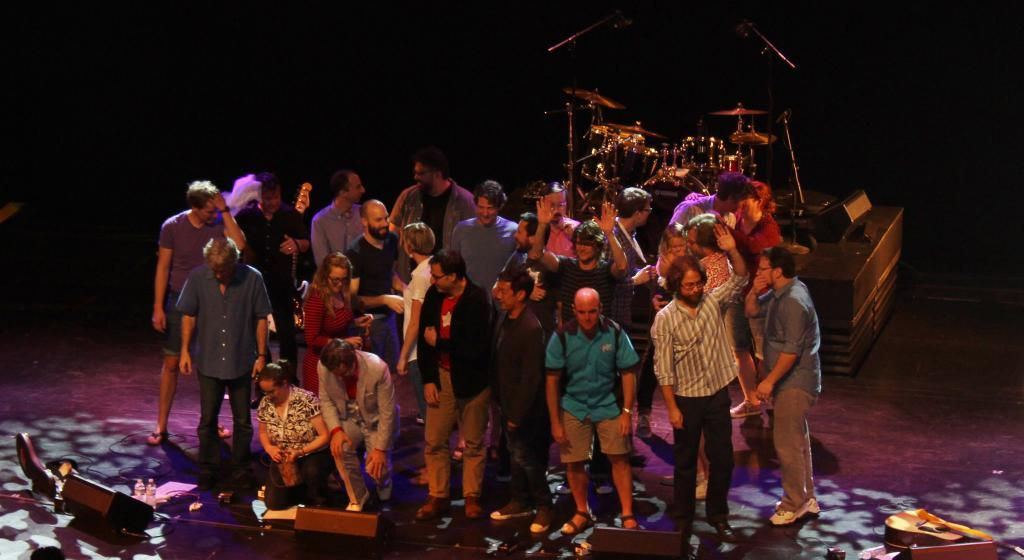How many people are in the image? There is a group of people in the image, but the exact number cannot be determined from the provided facts. What are the people in the image doing? The provided facts do not specify what the people are doing. What can be seen in the background of the image? Instruments are visible in the background of the image. How many quince are being processed in the image? There is no mention of quince or any processing activity in the image. 